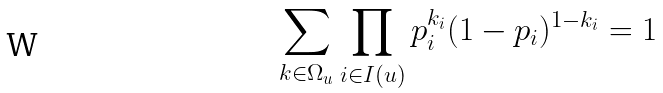<formula> <loc_0><loc_0><loc_500><loc_500>\sum _ { k \in \Omega _ { u } } \prod _ { i \in I ( u ) } p _ { i } ^ { k _ { i } } ( 1 - p _ { i } ) ^ { 1 - k _ { i } } = 1</formula> 